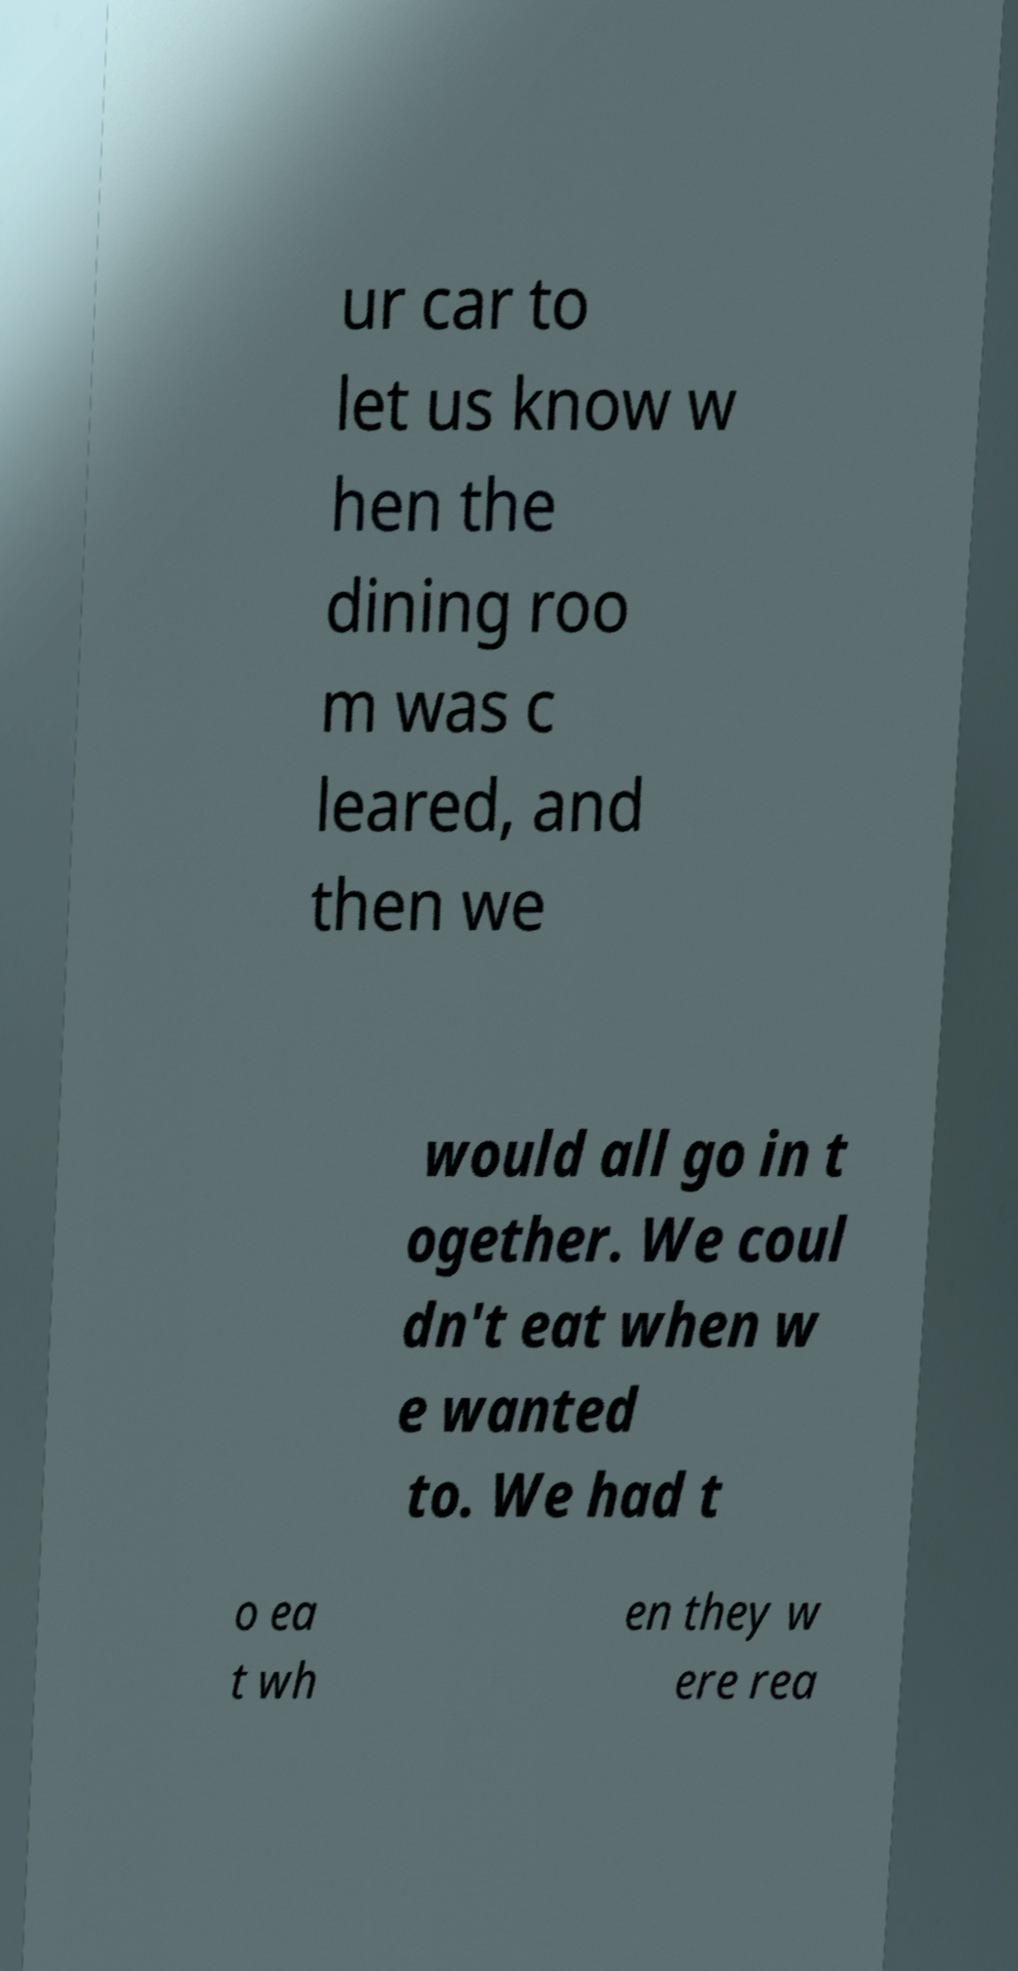Please read and relay the text visible in this image. What does it say? ur car to let us know w hen the dining roo m was c leared, and then we would all go in t ogether. We coul dn't eat when w e wanted to. We had t o ea t wh en they w ere rea 